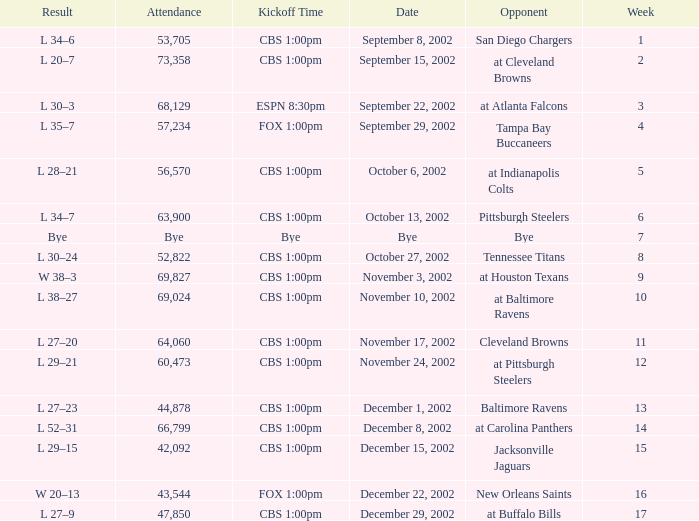What week number was the kickoff time cbs 1:00pm, with 60,473 people in attendance? 1.0. 